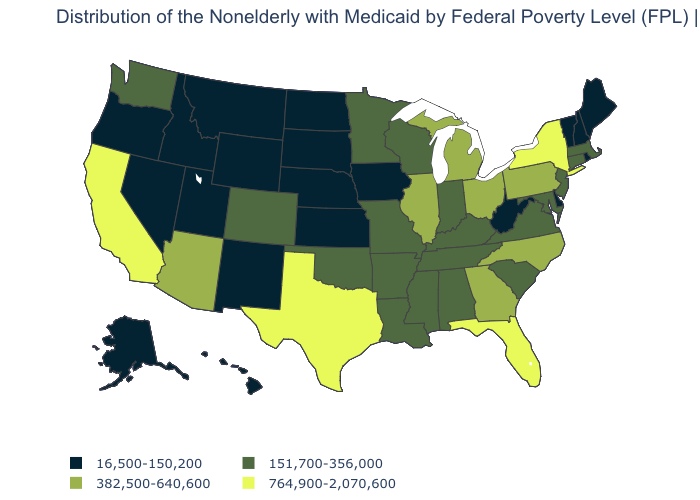Name the states that have a value in the range 382,500-640,600?
Concise answer only. Arizona, Georgia, Illinois, Michigan, North Carolina, Ohio, Pennsylvania. Is the legend a continuous bar?
Be succinct. No. Among the states that border Louisiana , does Texas have the highest value?
Concise answer only. Yes. What is the highest value in the USA?
Concise answer only. 764,900-2,070,600. Does New York have the highest value in the Northeast?
Write a very short answer. Yes. Name the states that have a value in the range 151,700-356,000?
Write a very short answer. Alabama, Arkansas, Colorado, Connecticut, Indiana, Kentucky, Louisiana, Maryland, Massachusetts, Minnesota, Mississippi, Missouri, New Jersey, Oklahoma, South Carolina, Tennessee, Virginia, Washington, Wisconsin. Which states have the lowest value in the MidWest?
Write a very short answer. Iowa, Kansas, Nebraska, North Dakota, South Dakota. Does the first symbol in the legend represent the smallest category?
Write a very short answer. Yes. Which states hav the highest value in the South?
Quick response, please. Florida, Texas. Is the legend a continuous bar?
Concise answer only. No. Name the states that have a value in the range 382,500-640,600?
Be succinct. Arizona, Georgia, Illinois, Michigan, North Carolina, Ohio, Pennsylvania. Among the states that border North Dakota , which have the lowest value?
Answer briefly. Montana, South Dakota. Name the states that have a value in the range 764,900-2,070,600?
Write a very short answer. California, Florida, New York, Texas. Does the first symbol in the legend represent the smallest category?
Short answer required. Yes. Name the states that have a value in the range 764,900-2,070,600?
Answer briefly. California, Florida, New York, Texas. 